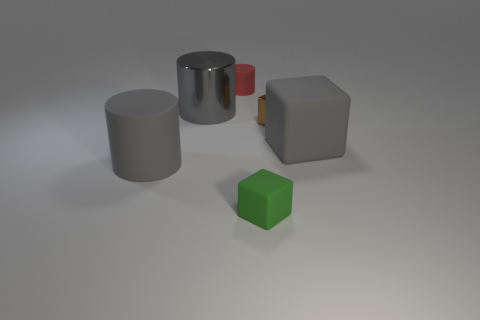Is the material of the big thing that is to the right of the tiny brown metallic cube the same as the big cylinder that is in front of the large gray metal object?
Your response must be concise. Yes. The rubber object that is the same color as the big rubber cylinder is what shape?
Make the answer very short. Cube. How many gray objects are the same material as the tiny cylinder?
Ensure brevity in your answer.  2. The large metallic cylinder is what color?
Make the answer very short. Gray. There is a large matte object in front of the gray rubber block; is it the same shape as the metallic object that is to the left of the tiny green thing?
Your answer should be very brief. Yes. There is a shiny thing that is left of the tiny red rubber object; what is its color?
Make the answer very short. Gray. Is the number of big gray matte cubes that are in front of the metal cylinder less than the number of cubes that are behind the large gray matte cylinder?
Your response must be concise. Yes. How many other things are made of the same material as the red cylinder?
Make the answer very short. 3. Do the small red thing and the brown object have the same material?
Offer a very short reply. No. What number of other objects are there of the same size as the brown block?
Your response must be concise. 2. 